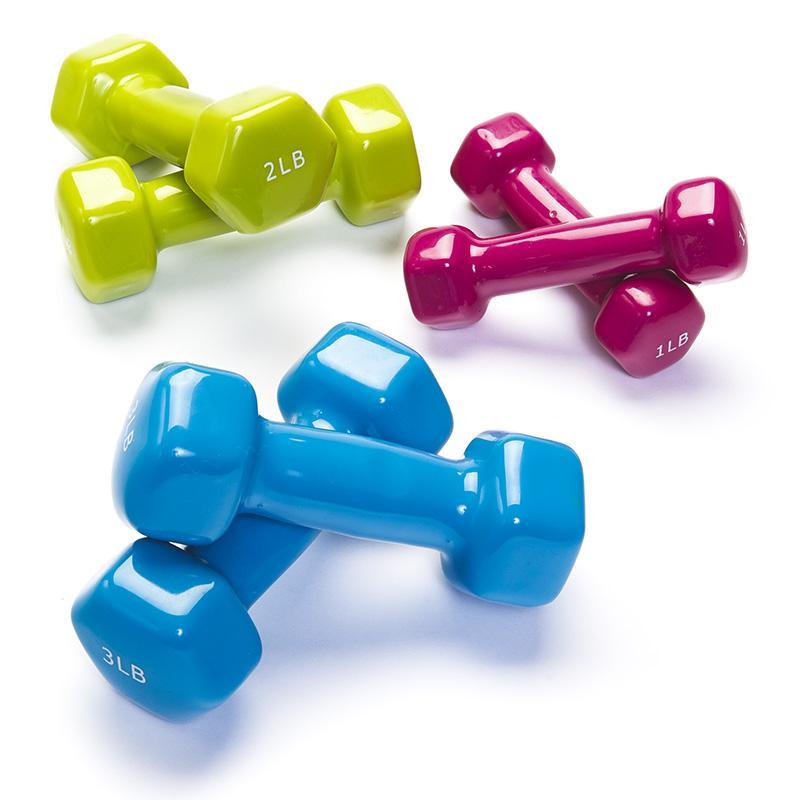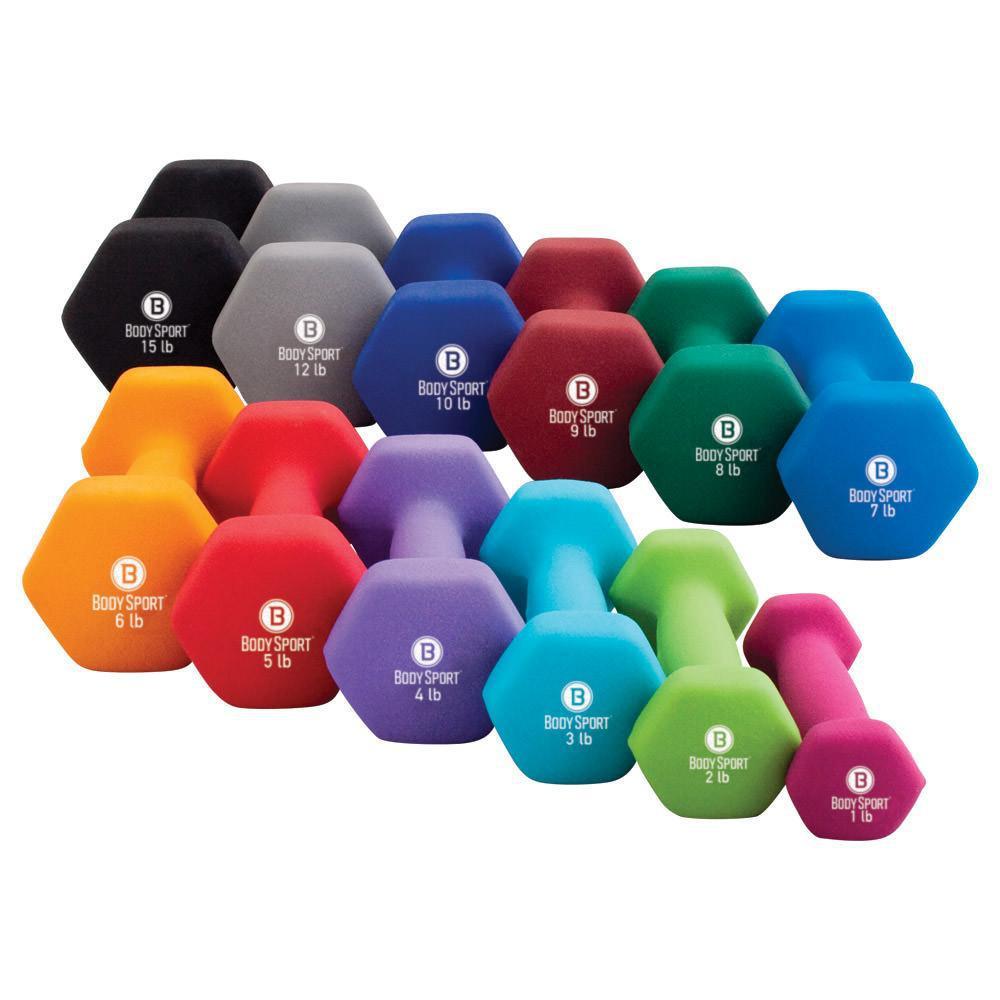The first image is the image on the left, the second image is the image on the right. Examine the images to the left and right. Is the description "One image features at least 10 different colors of dumbbells." accurate? Answer yes or no. Yes. The first image is the image on the left, the second image is the image on the right. Considering the images on both sides, is "In at least one image there is a total of 12 weights." valid? Answer yes or no. Yes. 